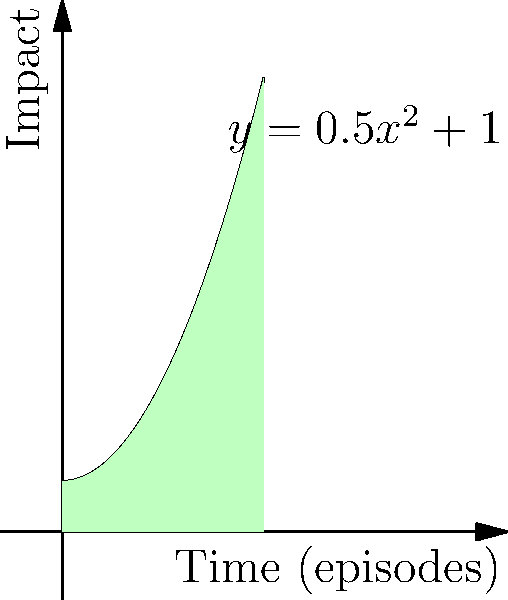In a television series, a character's actions have a cumulative impact over time, represented by the function $y = 0.5x^2 + 1$, where $y$ is the impact and $x$ is the number of episodes. Calculate the total impact of the character's actions over the first 4 episodes by finding the area under the curve. To find the area under the curve, we need to integrate the function from x = 0 to x = 4.

1) The function is $y = 0.5x^2 + 1$

2) We need to integrate this function: $\int_0^4 (0.5x^2 + 1) dx$

3) Integrating term by term:
   $\int 0.5x^2 dx = \frac{1}{6}x^3$
   $\int 1 dx = x$

4) So, the indefinite integral is: $\frac{1}{6}x^3 + x + C$

5) Now, we apply the limits:
   $[\frac{1}{6}x^3 + x]_0^4$

6) Substituting the upper limit:
   $\frac{1}{6}(4^3) + 4 = \frac{64}{6} + 4 = \frac{64}{6} + \frac{24}{6} = \frac{88}{6}$

7) Substituting the lower limit:
   $\frac{1}{6}(0^3) + 0 = 0$

8) The difference gives us the area:
   $\frac{88}{6} - 0 = \frac{88}{6} = 14\frac{2}{3}$

Therefore, the total impact over the first 4 episodes is $14\frac{2}{3}$ units.
Answer: $14\frac{2}{3}$ units 